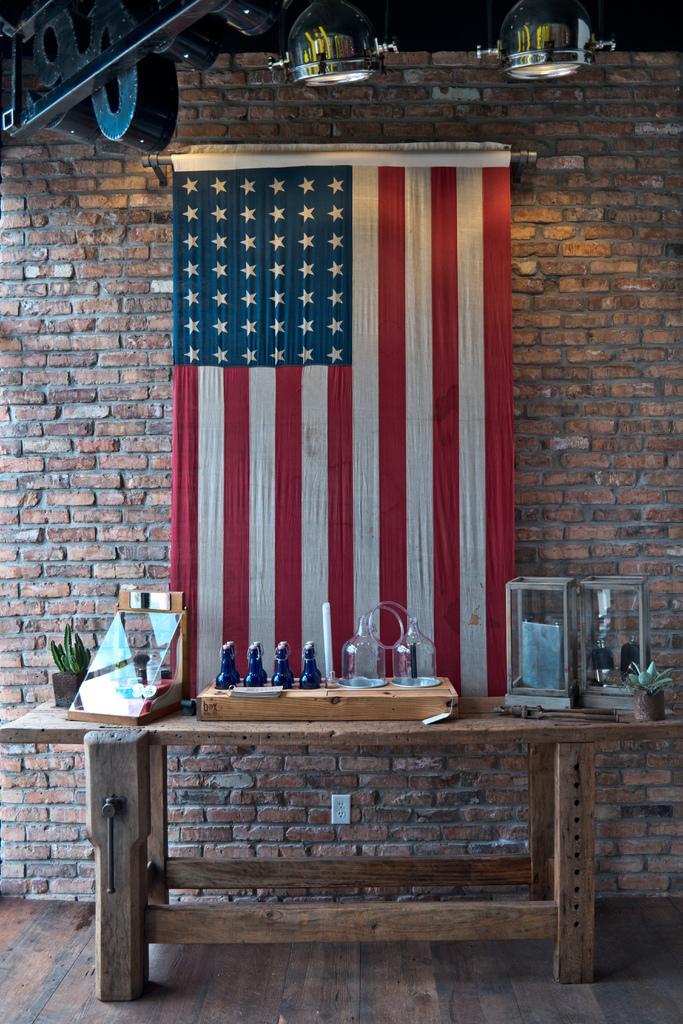Describe this image in one or two sentences. In the given picture there is a national flag of one country on the table. And there are some bottles, some plants on the table. In the background we can observe a wall here and some lighting to the ceiling. 